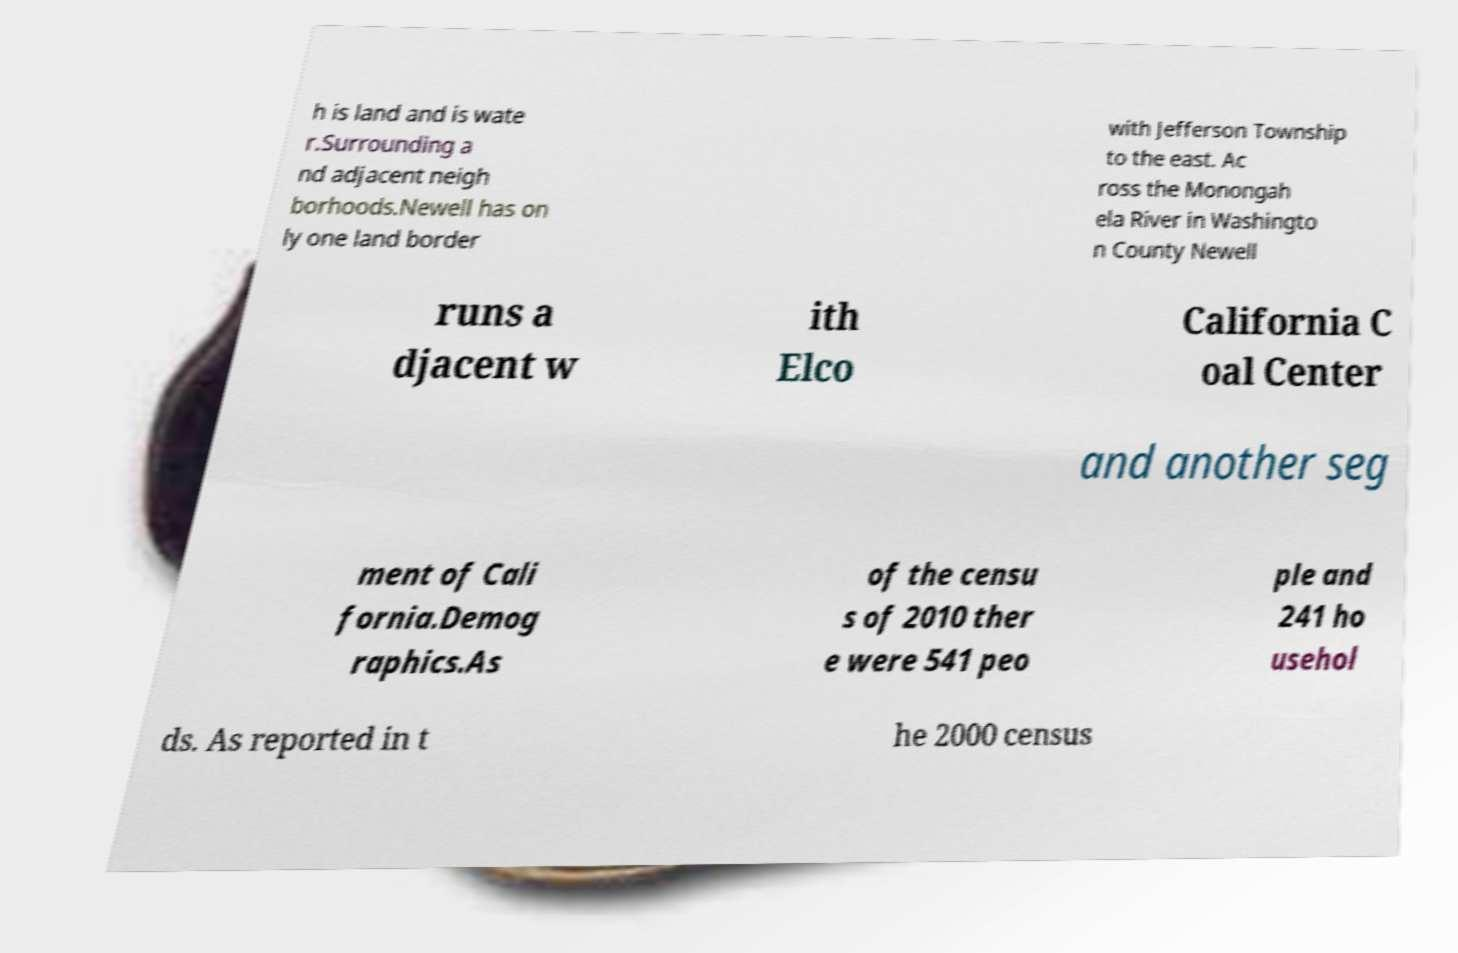Please identify and transcribe the text found in this image. h is land and is wate r.Surrounding a nd adjacent neigh borhoods.Newell has on ly one land border with Jefferson Township to the east. Ac ross the Monongah ela River in Washingto n County Newell runs a djacent w ith Elco California C oal Center and another seg ment of Cali fornia.Demog raphics.As of the censu s of 2010 ther e were 541 peo ple and 241 ho usehol ds. As reported in t he 2000 census 